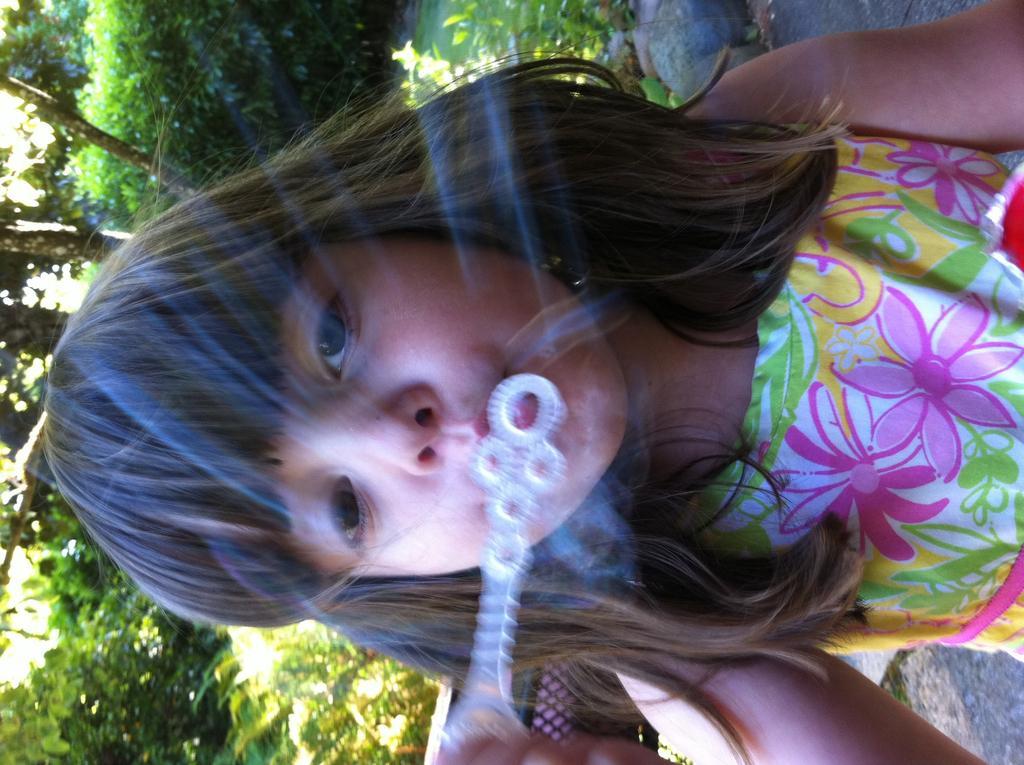Can you describe this image briefly? In the picture there is a girl, she is blowing a bubble, there are trees behind her. 